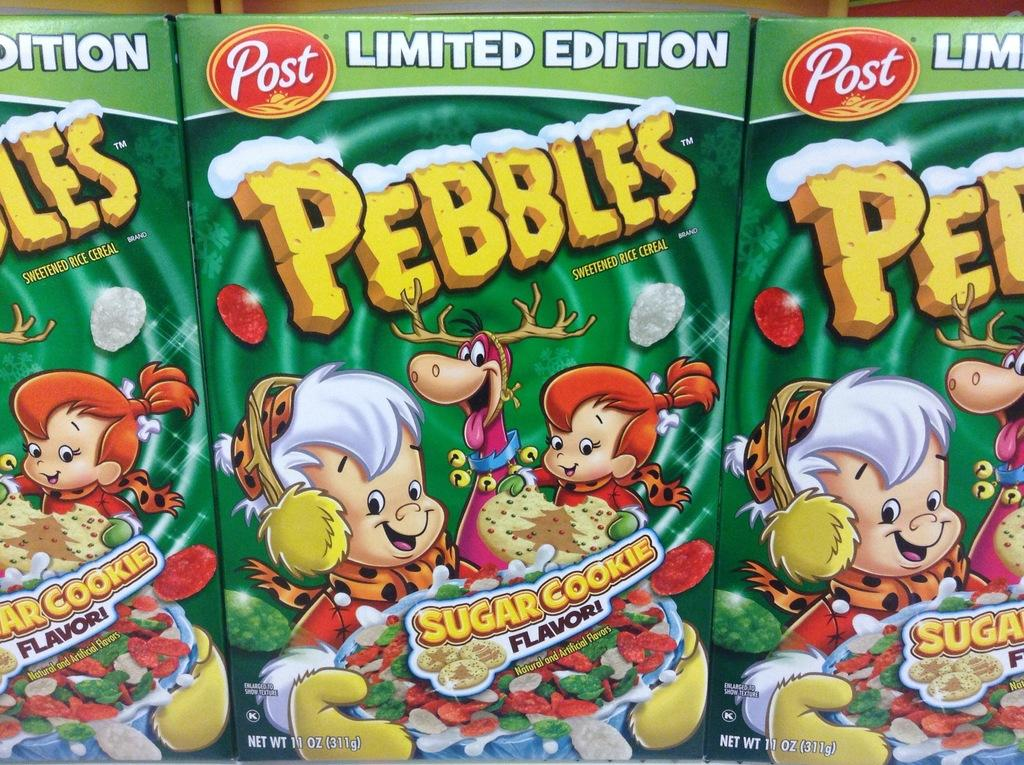What objects are in the foreground of the image? There are three green cookie boxes in the foreground of the image. What can be found on the cookie boxes? There is text and images on the cookie boxes. What type of structure can be seen in the background of the image? There is no structure visible in the background of the image; it only features the green cookie boxes. How many dolls are sitting on top of the cookie boxes? There are: There are no dolls present in the image. 